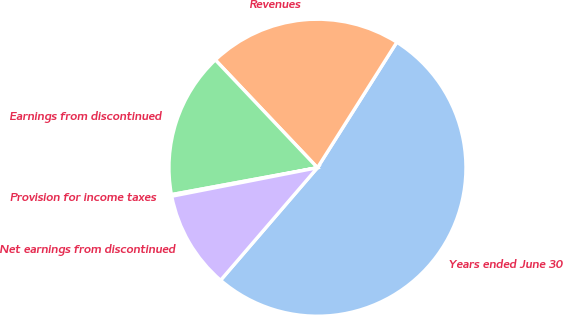Convert chart to OTSL. <chart><loc_0><loc_0><loc_500><loc_500><pie_chart><fcel>Years ended June 30<fcel>Revenues<fcel>Earnings from discontinued<fcel>Provision for income taxes<fcel>Net earnings from discontinued<nl><fcel>52.33%<fcel>21.04%<fcel>15.83%<fcel>0.18%<fcel>10.61%<nl></chart> 